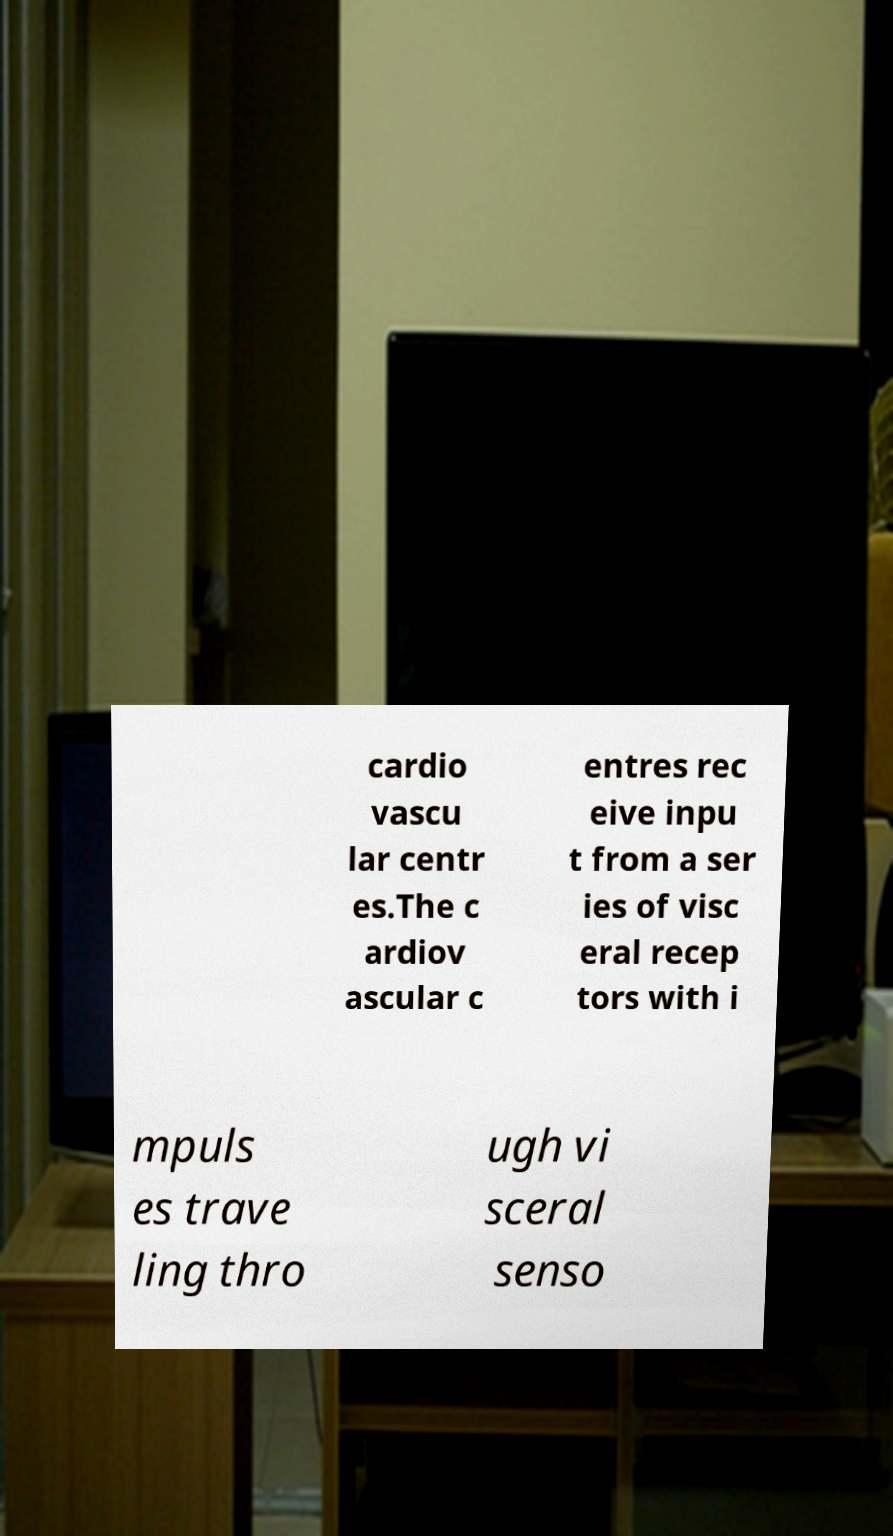Please identify and transcribe the text found in this image. cardio vascu lar centr es.The c ardiov ascular c entres rec eive inpu t from a ser ies of visc eral recep tors with i mpuls es trave ling thro ugh vi sceral senso 